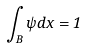Convert formula to latex. <formula><loc_0><loc_0><loc_500><loc_500>\int _ { B } \psi d x = 1</formula> 